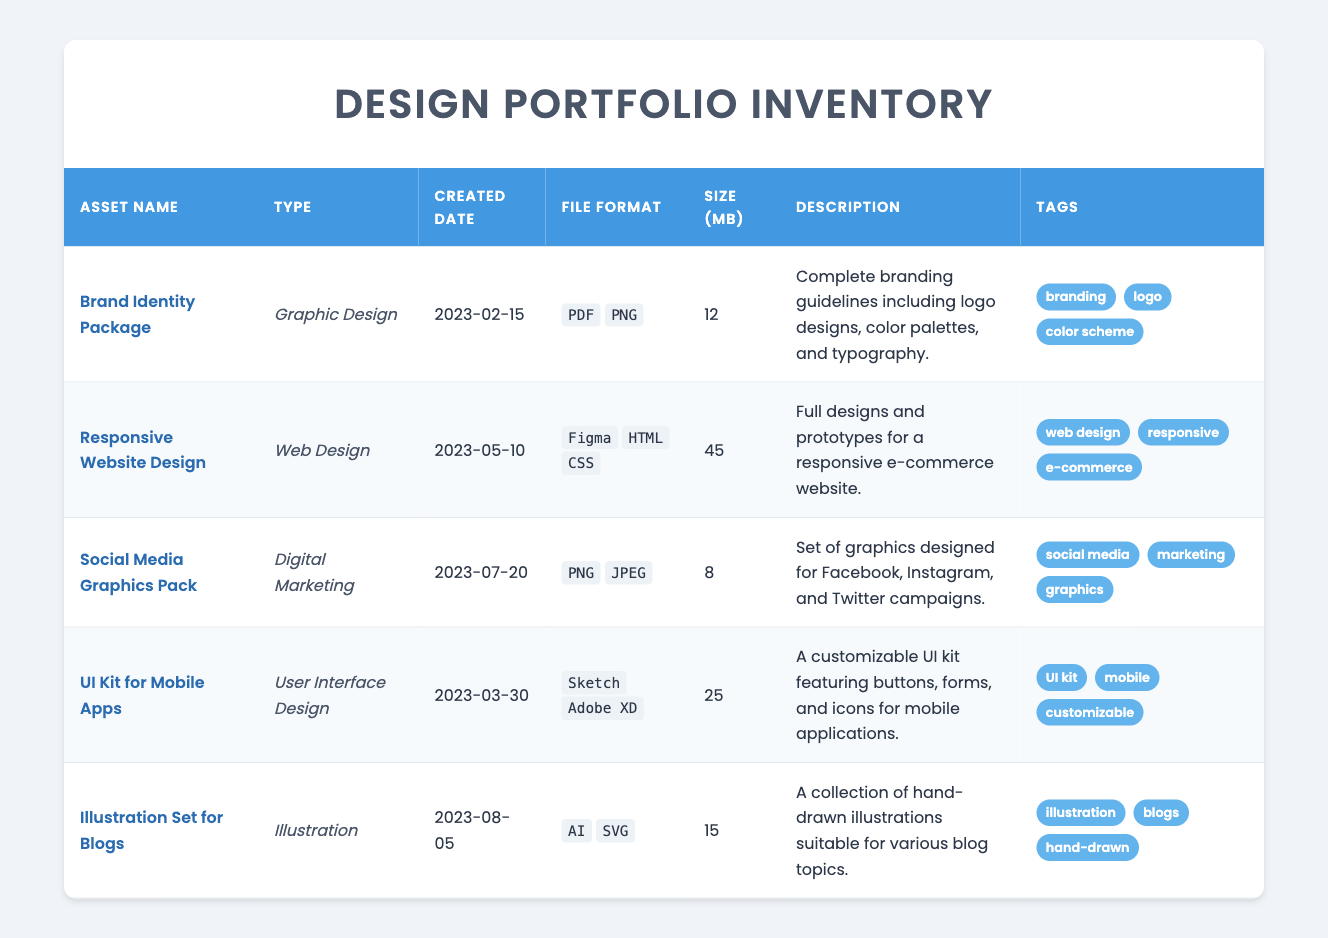What is the file format of the Brand Identity Package? The Brand Identity Package has two file formats listed: PDF and PNG. This information can be directly retrieved from the table under the "File Format" column for that specific asset.
Answer: PDF, PNG How many assets were created after March 2023? To find this, we look at the "Created Date" column for each asset. The assets created after March 2023 are the "Responsive Website Design," "Social Media Graphics Pack," and "Illustration Set for Blogs," totaling three assets.
Answer: 3 Which asset type has the largest file size? We compare the sizes of all assets listed in the "Size (MB)" column. The "Responsive Website Design" has the largest size at 45 MB. Therefore, its asset type, which is "Web Design," is the answer.
Answer: Web Design Do any assets include the tag "UI kit"? Looking at the tags for each asset, only the "UI Kit for Mobile Apps" includes the tag "UI kit." This can be verified in the "Tags" column of the respective asset.
Answer: Yes Calculate the average size of the assets in megabytes. The sizes of all assets are 12, 45, 8, 25, and 15 MB. The sum is 12 + 45 + 8 + 25 + 15 = 105 MB. There are 5 assets, so the average size is 105 / 5 = 21 MB.
Answer: 21 Is there an asset with the description that mentions social media? The "Social Media Graphics Pack" has a description mentioning that it is designed for Facebook, Instagram, and Twitter campaigns, confirming that it relates to social media.
Answer: Yes Which asset has the earliest created date? By examining the "Created Date" column, we find that the "Brand Identity Package" was created on February 15, 2023, which is the earliest date when compared to the other assets listed.
Answer: Brand Identity Package How many total tags are there across all assets? We count the tags from each asset: "Branding," "Logo," "Color scheme" (3), "Web design," "Responsive," "E-commerce" (3), "Social media," "Marketing," "Graphics" (3), "UI kit," "Mobile," "Customizable" (3), and "Illustration," "Blogs," "Hand-drawn" (3). This gives us 15 unique tags across all assets.
Answer: 15 What is the description of the Responsive Website Design asset? By looking under the "Description" column for the "Responsive Website Design," we see its description is that it includes full designs and prototypes for a responsive e-commerce website.
Answer: Full designs and prototypes for a responsive e-commerce website 